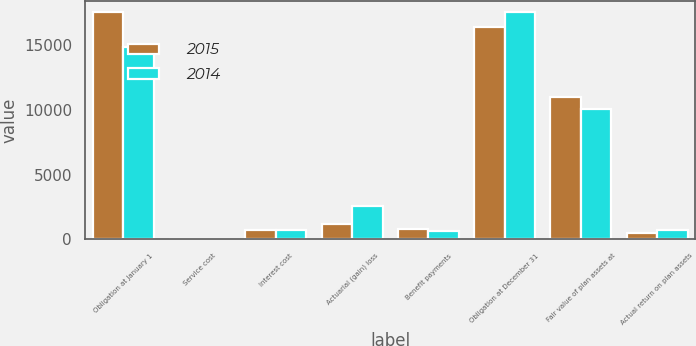<chart> <loc_0><loc_0><loc_500><loc_500><stacked_bar_chart><ecel><fcel>Obligation at January 1<fcel>Service cost<fcel>Interest cost<fcel>Actuarial (gain) loss<fcel>Benefit payments<fcel>Obligation at December 31<fcel>Fair value of plan assets at<fcel>Actual return on plan assets<nl><fcel>2015<fcel>17594<fcel>2<fcel>737<fcel>1159<fcel>776<fcel>16395<fcel>10986<fcel>506<nl><fcel>2014<fcel>14899<fcel>3<fcel>746<fcel>2573<fcel>607<fcel>17594<fcel>10057<fcel>746<nl></chart> 